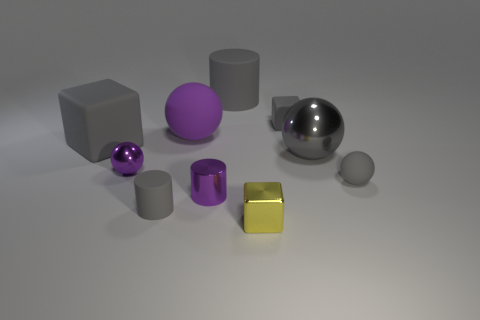Are there any cylinders that are right of the tiny gray object behind the big gray sphere?
Ensure brevity in your answer.  No. There is another ball that is the same color as the small matte sphere; what size is it?
Your answer should be very brief. Large. What shape is the small matte object that is left of the small shiny block?
Offer a very short reply. Cylinder. How many tiny yellow metal objects are behind the gray rubber cylinder that is behind the small gray rubber thing that is behind the gray rubber ball?
Ensure brevity in your answer.  0. Is the size of the metal block the same as the gray rubber cylinder behind the tiny purple metallic cylinder?
Your answer should be compact. No. There is a yellow thing in front of the gray metallic object to the right of the large purple sphere; what size is it?
Make the answer very short. Small. How many yellow things are the same material as the large gray sphere?
Your answer should be compact. 1. Are there any large rubber objects?
Provide a short and direct response. Yes. What size is the gray matte thing that is in front of the tiny gray matte sphere?
Provide a succinct answer. Small. What number of tiny shiny cylinders are the same color as the big rubber cylinder?
Make the answer very short. 0. 